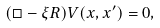Convert formula to latex. <formula><loc_0><loc_0><loc_500><loc_500>( \Box - \xi R ) V ( x , x ^ { \prime } ) = 0 ,</formula> 